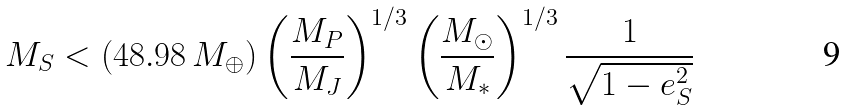Convert formula to latex. <formula><loc_0><loc_0><loc_500><loc_500>M _ { S } < \left ( 4 8 . 9 8 \, M _ { \oplus } \right ) \left ( \frac { M _ { P } } { M _ { J } } \right ) ^ { 1 / 3 } \left ( \frac { M _ { \odot } } { M _ { * } } \right ) ^ { 1 / 3 } \frac { 1 } { \sqrt { 1 - e _ { S } ^ { 2 } } }</formula> 